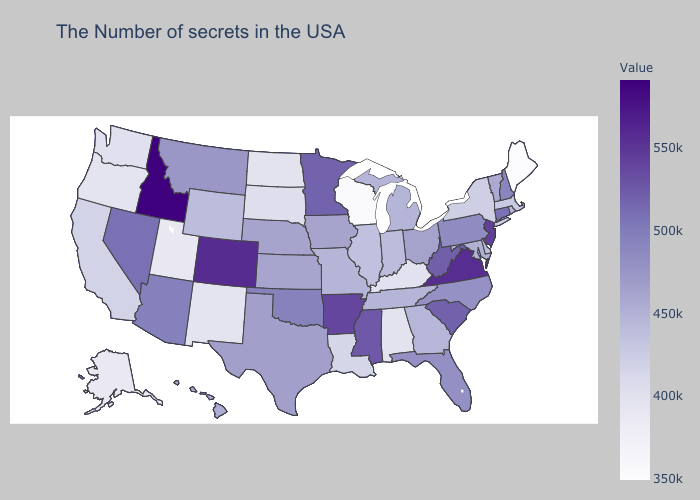Does Georgia have a higher value than Arizona?
Short answer required. No. Does the map have missing data?
Keep it brief. No. Among the states that border California , does Oregon have the highest value?
Write a very short answer. No. Does Virginia have the highest value in the USA?
Give a very brief answer. No. Which states have the lowest value in the USA?
Give a very brief answer. Maine. 